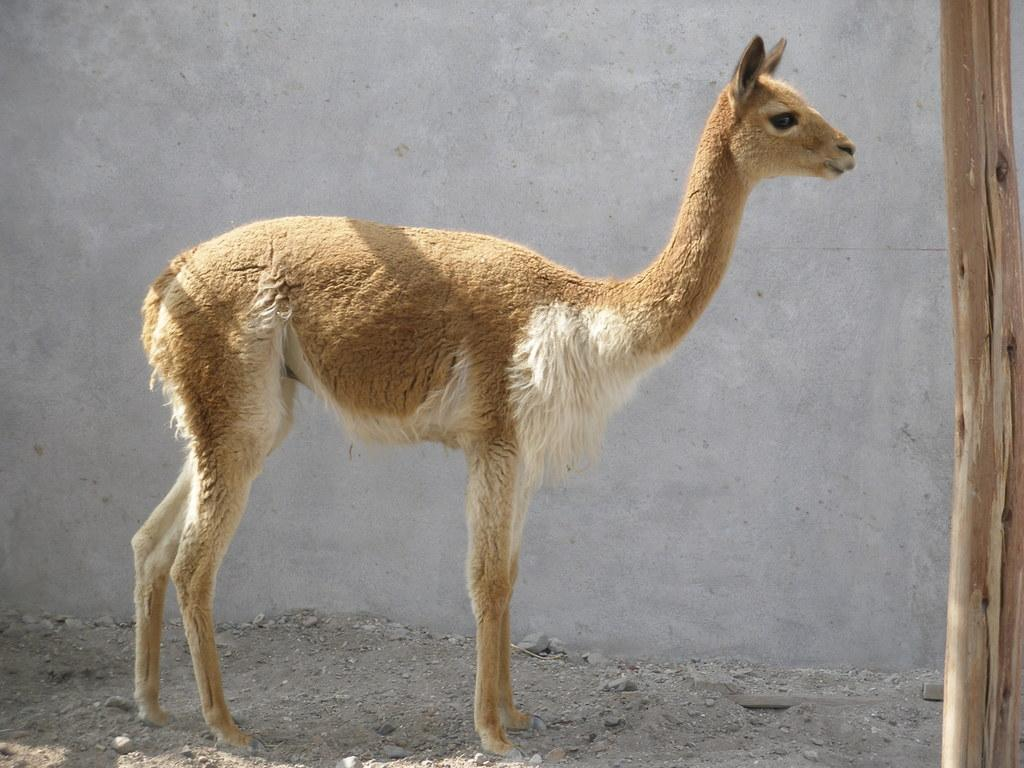What type of animal is in the image? There is a fawn in the image. What is the fawn standing in front of? The fawn is standing before a cement wall. What can be seen on the right side of the image? There is a wooden pole on the right side of the image. What type of jar is the fawn holding in the image? There is no jar present in the image; the fawn is not holding anything. 